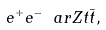<formula> <loc_0><loc_0><loc_500><loc_500>e ^ { + } e ^ { - } \ a r Z t \bar { t } ,</formula> 